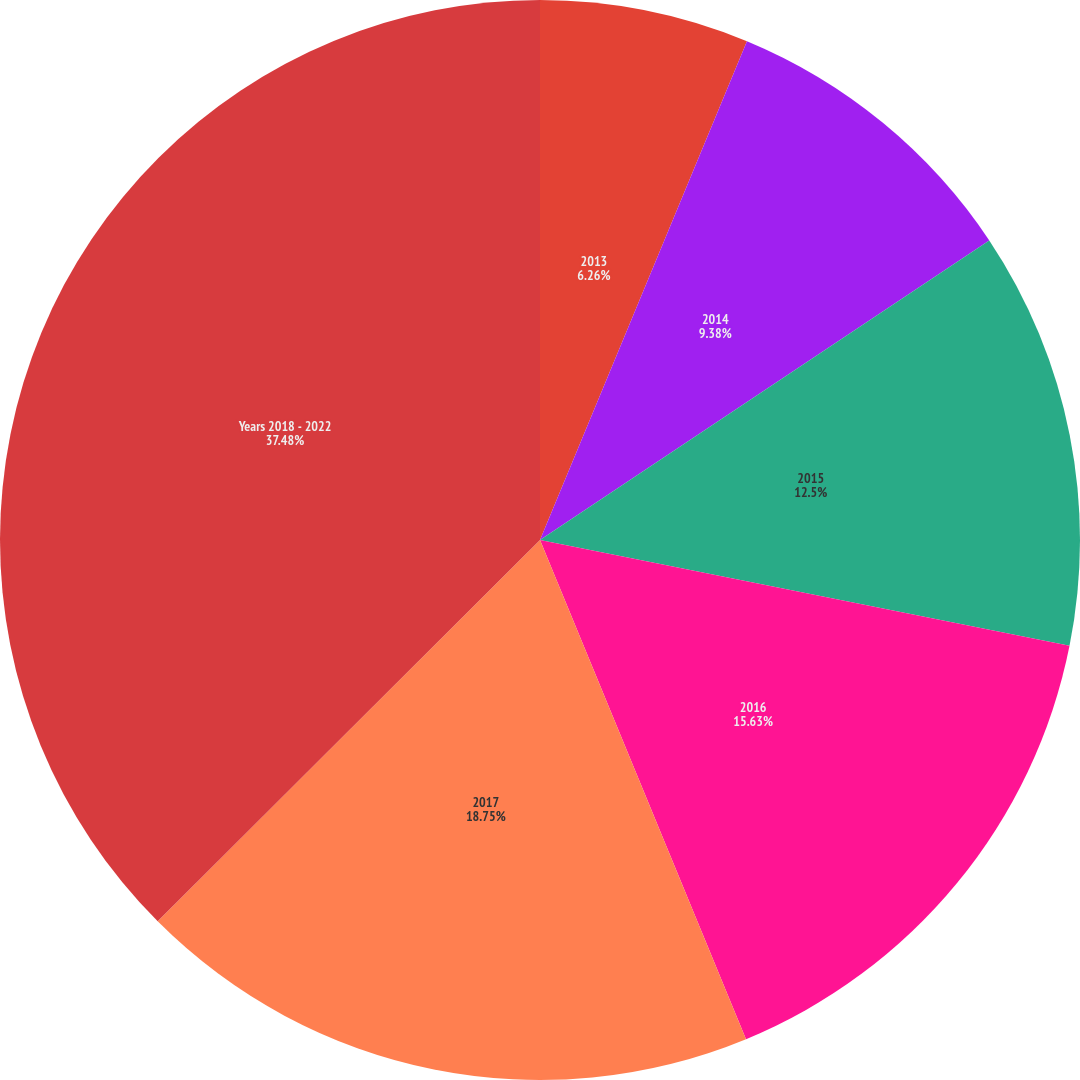Convert chart to OTSL. <chart><loc_0><loc_0><loc_500><loc_500><pie_chart><fcel>2013<fcel>2014<fcel>2015<fcel>2016<fcel>2017<fcel>Years 2018 - 2022<nl><fcel>6.26%<fcel>9.38%<fcel>12.5%<fcel>15.63%<fcel>18.75%<fcel>37.48%<nl></chart> 